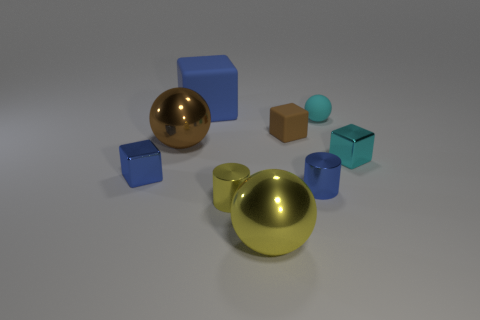There is a big sphere that is the same color as the tiny rubber cube; what is it made of?
Your answer should be compact. Metal. There is a small blue object that is on the right side of the large blue block; is it the same shape as the tiny matte object on the left side of the cyan matte sphere?
Make the answer very short. No. What is the material of the brown block that is the same size as the cyan matte ball?
Ensure brevity in your answer.  Rubber. Does the cylinder that is on the left side of the small blue shiny cylinder have the same material as the blue object to the left of the large blue block?
Provide a short and direct response. Yes. The yellow object that is the same size as the blue matte block is what shape?
Keep it short and to the point. Sphere. What number of other objects are the same color as the tiny rubber ball?
Provide a short and direct response. 1. There is a tiny object that is to the left of the large brown metallic thing; what is its color?
Your response must be concise. Blue. How many other things are there of the same material as the small brown object?
Give a very brief answer. 2. Are there more tiny yellow cylinders behind the cyan metallic object than blue metal blocks behind the large brown metallic sphere?
Provide a succinct answer. No. What number of balls are on the right side of the tiny cyan rubber ball?
Provide a short and direct response. 0. 